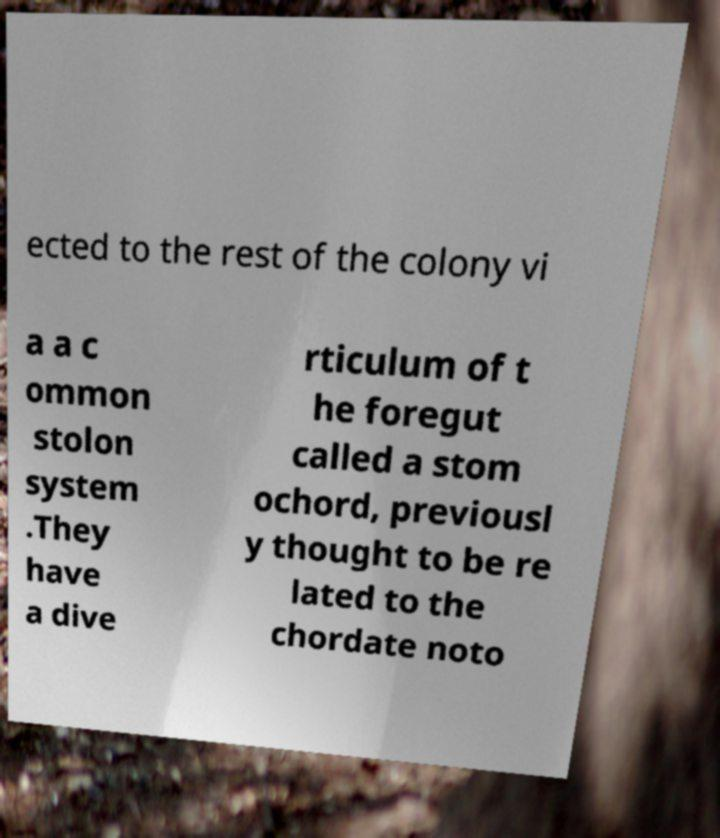Please read and relay the text visible in this image. What does it say? ected to the rest of the colony vi a a c ommon stolon system .They have a dive rticulum of t he foregut called a stom ochord, previousl y thought to be re lated to the chordate noto 